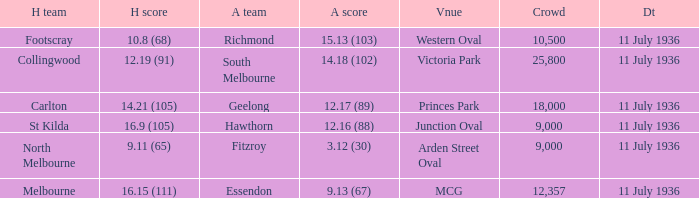What Away team got a team score of 12.16 (88)? Hawthorn. 